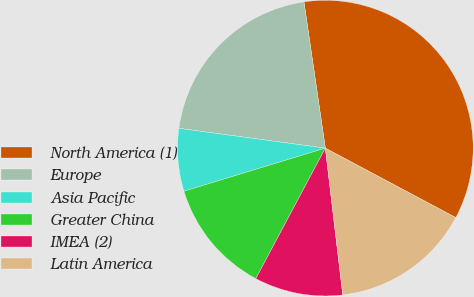Convert chart. <chart><loc_0><loc_0><loc_500><loc_500><pie_chart><fcel>North America (1)<fcel>Europe<fcel>Asia Pacific<fcel>Greater China<fcel>IMEA (2)<fcel>Latin America<nl><fcel>35.1%<fcel>20.55%<fcel>6.85%<fcel>12.5%<fcel>9.67%<fcel>15.33%<nl></chart> 